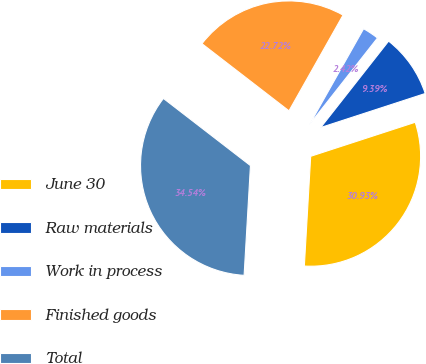<chart> <loc_0><loc_0><loc_500><loc_500><pie_chart><fcel>June 30<fcel>Raw materials<fcel>Work in process<fcel>Finished goods<fcel>Total<nl><fcel>30.93%<fcel>9.39%<fcel>2.42%<fcel>22.72%<fcel>34.54%<nl></chart> 